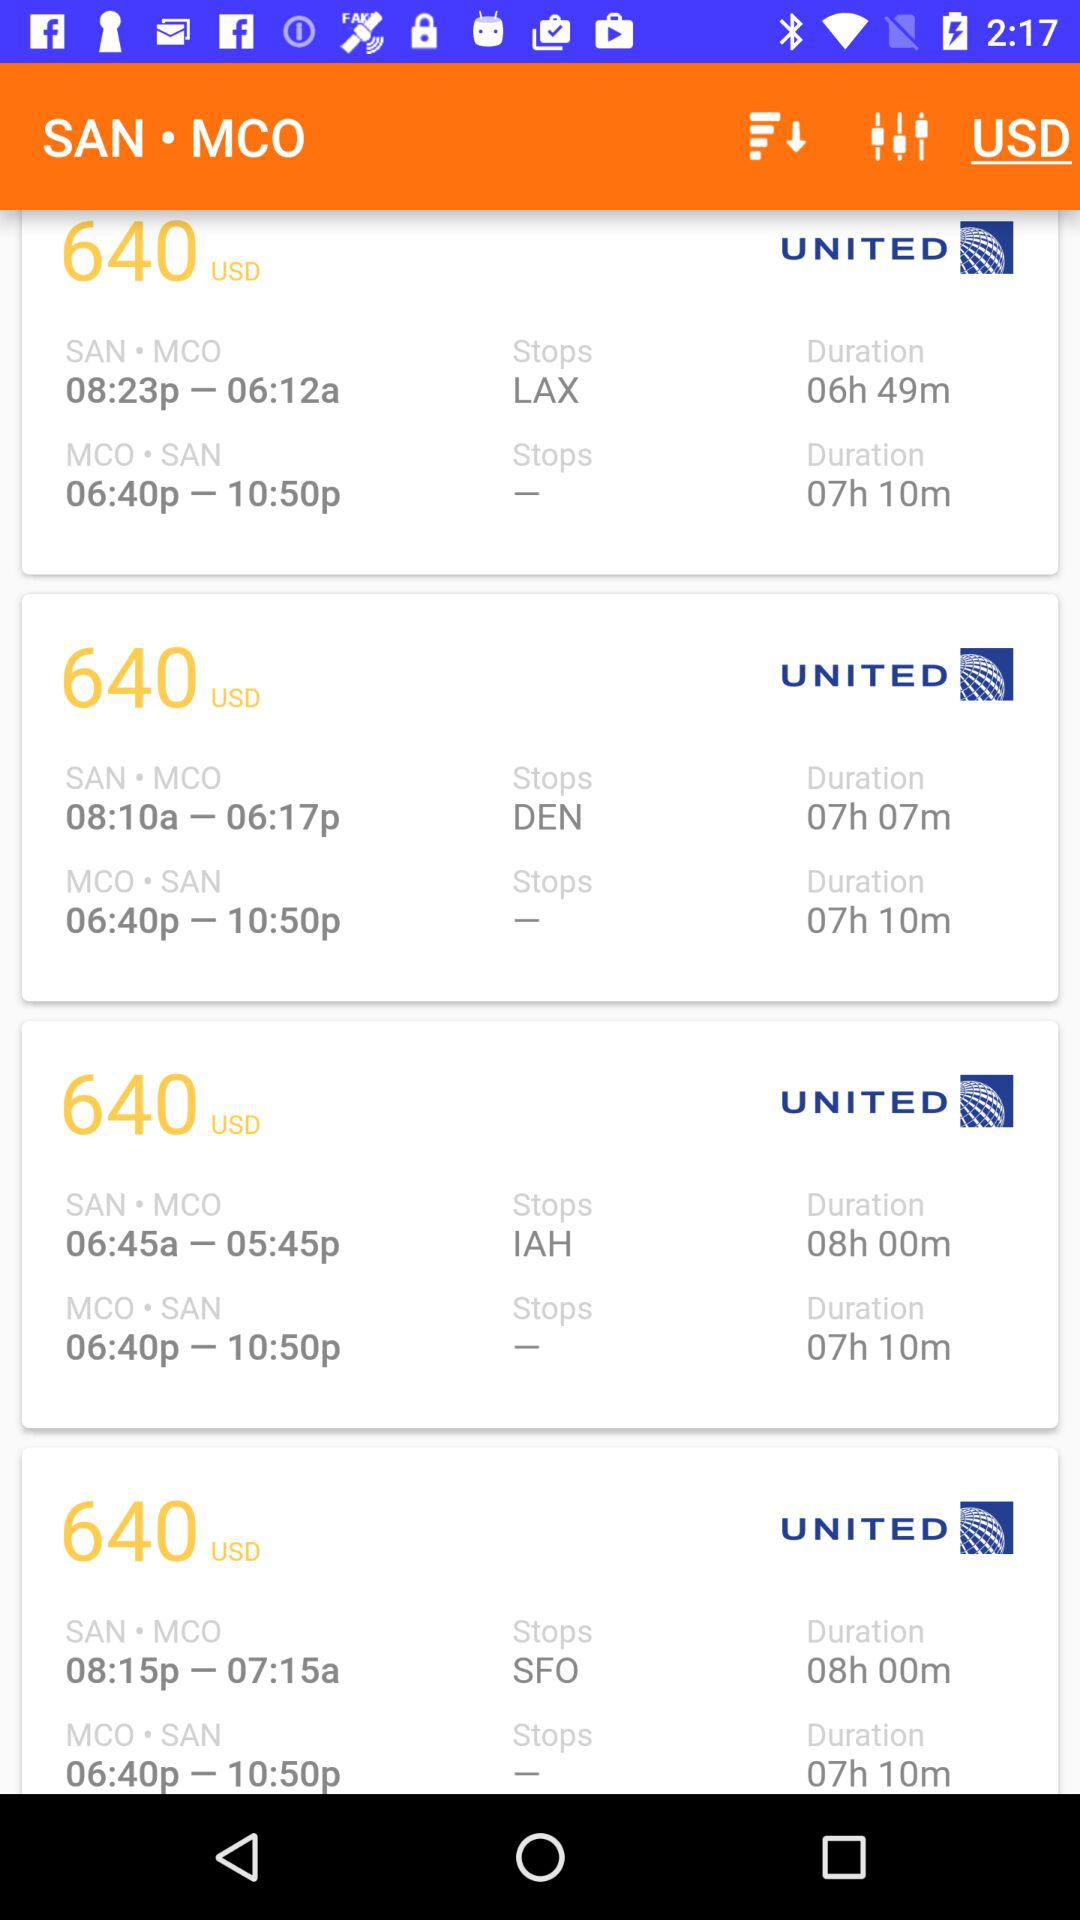How many seats are available on the SAN to MCO flight that stops in DEN?
When the provided information is insufficient, respond with <no answer>. <no answer> 